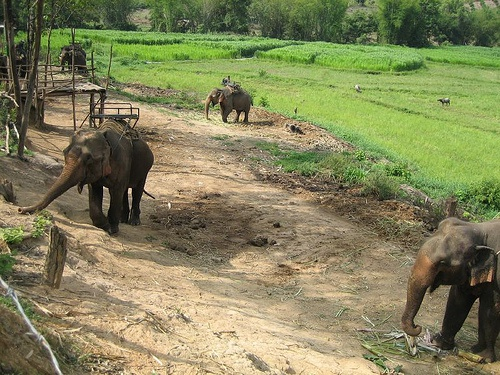Describe the objects in this image and their specific colors. I can see elephant in black and gray tones, elephant in black and gray tones, elephant in black, darkgreen, tan, and gray tones, elephant in black, gray, and darkgreen tones, and elephant in black, darkgreen, and gray tones in this image. 